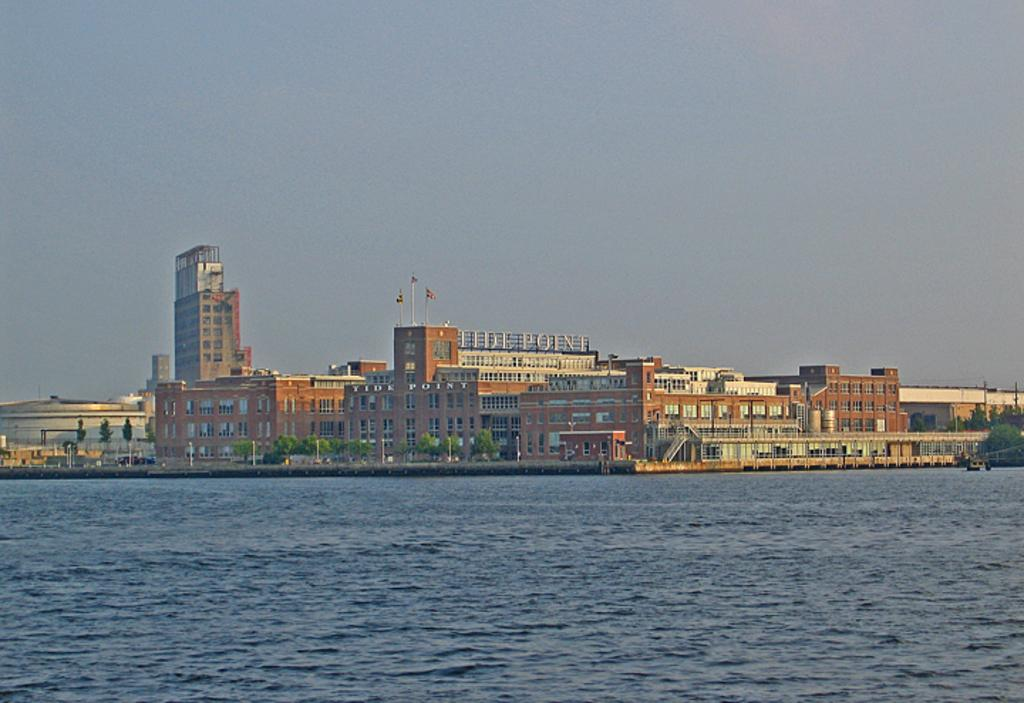What is visible in the image? Water, buildings, trees, and clouds are present in the image. Can you describe the buildings in the image? The image shows buildings, but their specific characteristics are not mentioned in the facts. What type of vegetation is present in the image? Trees are present in the image. What is the condition of the sky in the image? Clouds are present in the sky in the image. Where is the camera located in the image? There is no camera present in the image; it is a photograph or image taken by a camera. What type of boundary can be seen in the image? There is no boundary mentioned or visible in the image. 